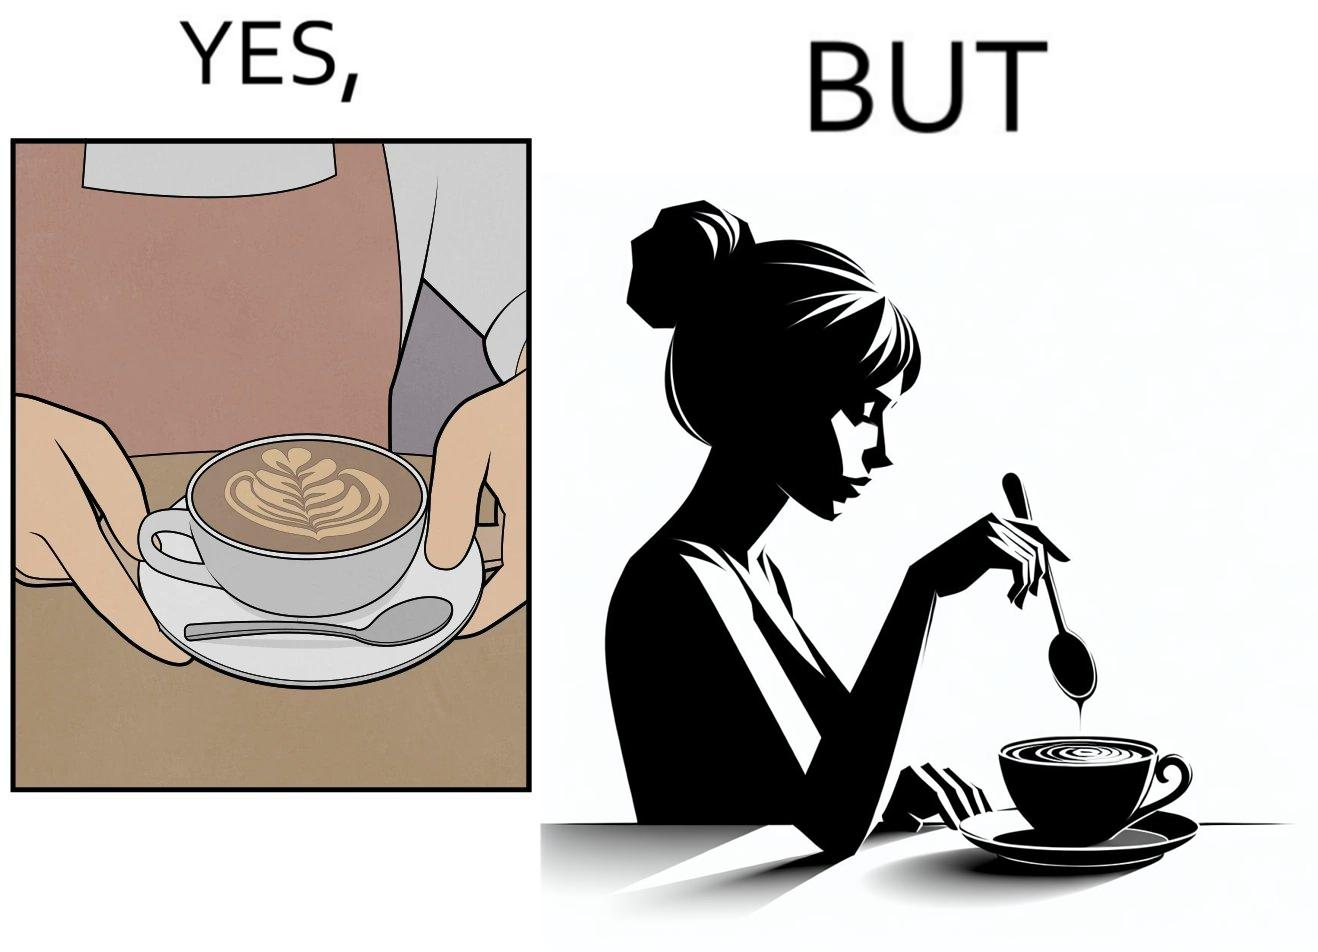Provide a description of this image. The image is ironic, because even when the coffee maker create latte art to make coffee look attractive but it is there just for a short time after that it is vanished 